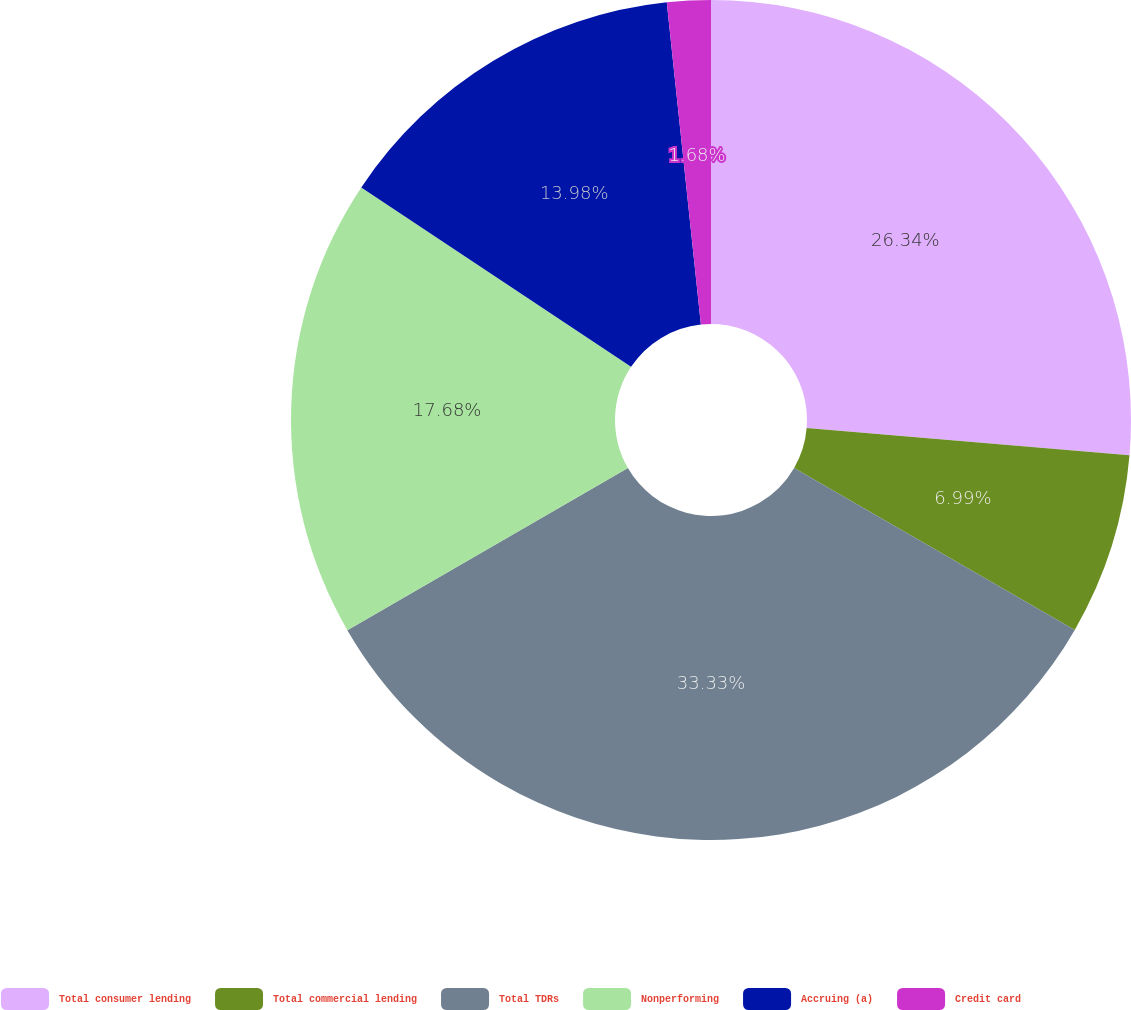Convert chart to OTSL. <chart><loc_0><loc_0><loc_500><loc_500><pie_chart><fcel>Total consumer lending<fcel>Total commercial lending<fcel>Total TDRs<fcel>Nonperforming<fcel>Accruing (a)<fcel>Credit card<nl><fcel>26.34%<fcel>6.99%<fcel>33.33%<fcel>17.68%<fcel>13.98%<fcel>1.68%<nl></chart> 